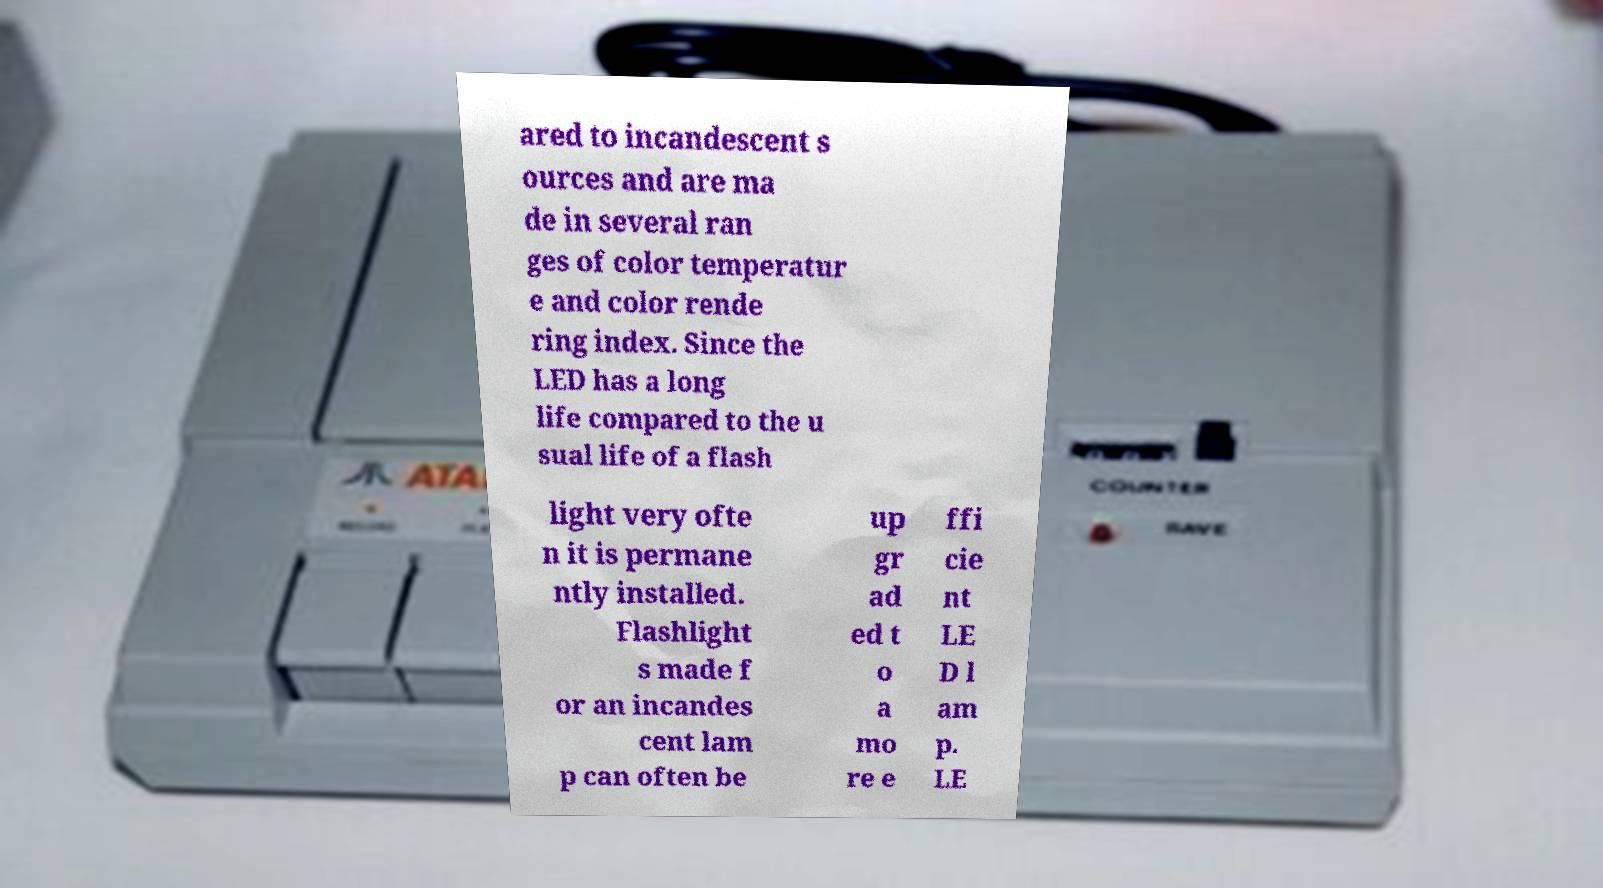What messages or text are displayed in this image? I need them in a readable, typed format. ared to incandescent s ources and are ma de in several ran ges of color temperatur e and color rende ring index. Since the LED has a long life compared to the u sual life of a flash light very ofte n it is permane ntly installed. Flashlight s made f or an incandes cent lam p can often be up gr ad ed t o a mo re e ffi cie nt LE D l am p. LE 